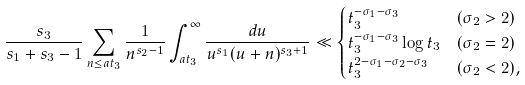Convert formula to latex. <formula><loc_0><loc_0><loc_500><loc_500>\frac { s _ { 3 } } { s _ { 1 } + s _ { 3 } - 1 } \sum _ { n \leq a t _ { 3 } } \frac { 1 } { n ^ { s _ { 2 } - 1 } } \int _ { a t _ { 3 } } ^ { \infty } \frac { d u } { u ^ { s _ { 1 } } ( u + n ) ^ { s _ { 3 } + 1 } } & \ll \begin{cases} t _ { 3 } ^ { - \sigma _ { 1 } - \sigma _ { 3 } } & ( \sigma _ { 2 } > 2 ) \\ t _ { 3 } ^ { - \sigma _ { 1 } - \sigma _ { 3 } } \log t _ { 3 } & ( \sigma _ { 2 } = 2 ) \\ t _ { 3 } ^ { 2 - \sigma _ { 1 } - \sigma _ { 2 } - \sigma _ { 3 } } & ( \sigma _ { 2 } < 2 ) , \\ \end{cases}</formula> 